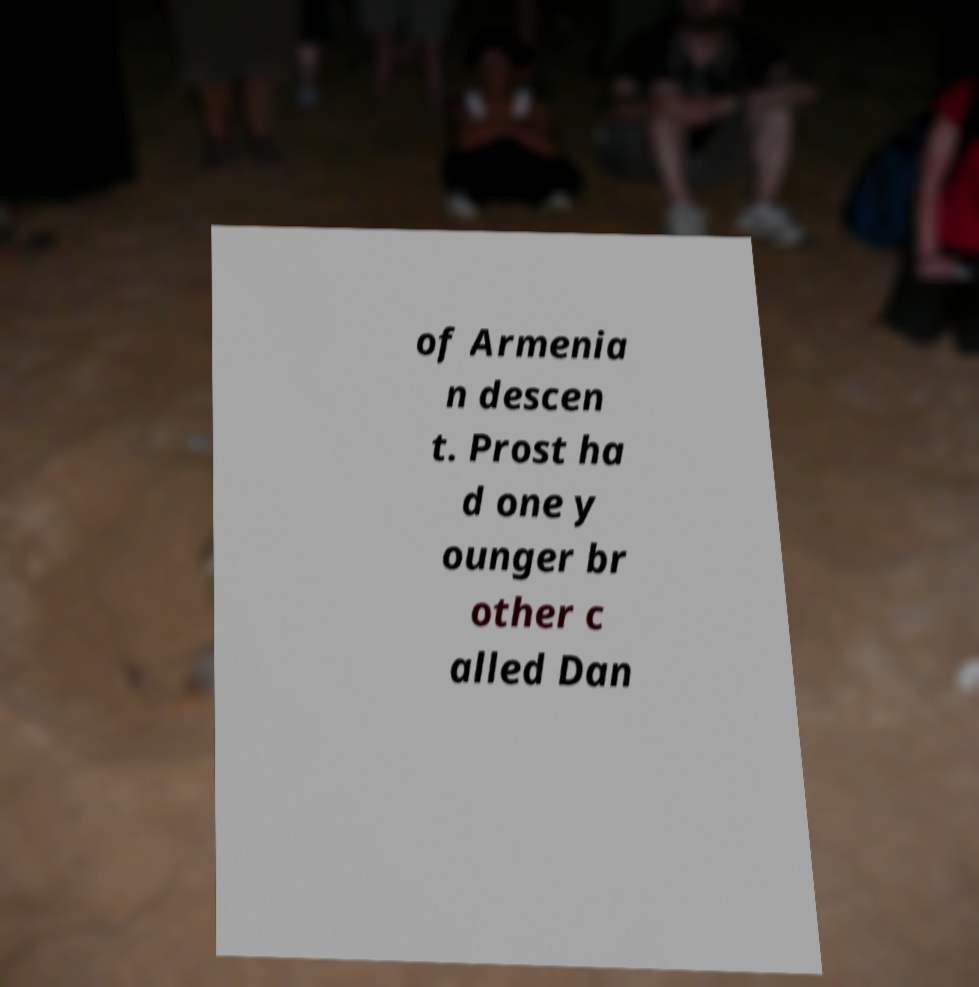What messages or text are displayed in this image? I need them in a readable, typed format. of Armenia n descen t. Prost ha d one y ounger br other c alled Dan 